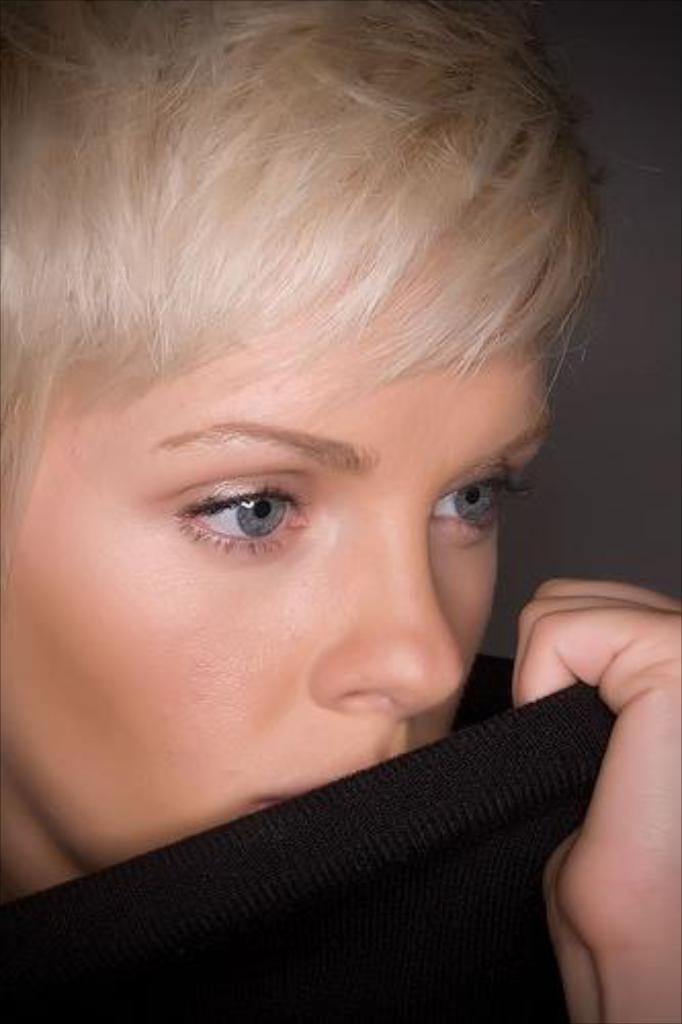What is the main subject of the image? There is a person in the image. What is the person holding in the image? The person is holding a black color cloth. What color is the background of the image? The background of the image is grey. Can you see any ducks in the image? No, there are no ducks present in the image. Is there a train visible in the image? No, there is no train visible in the image. 